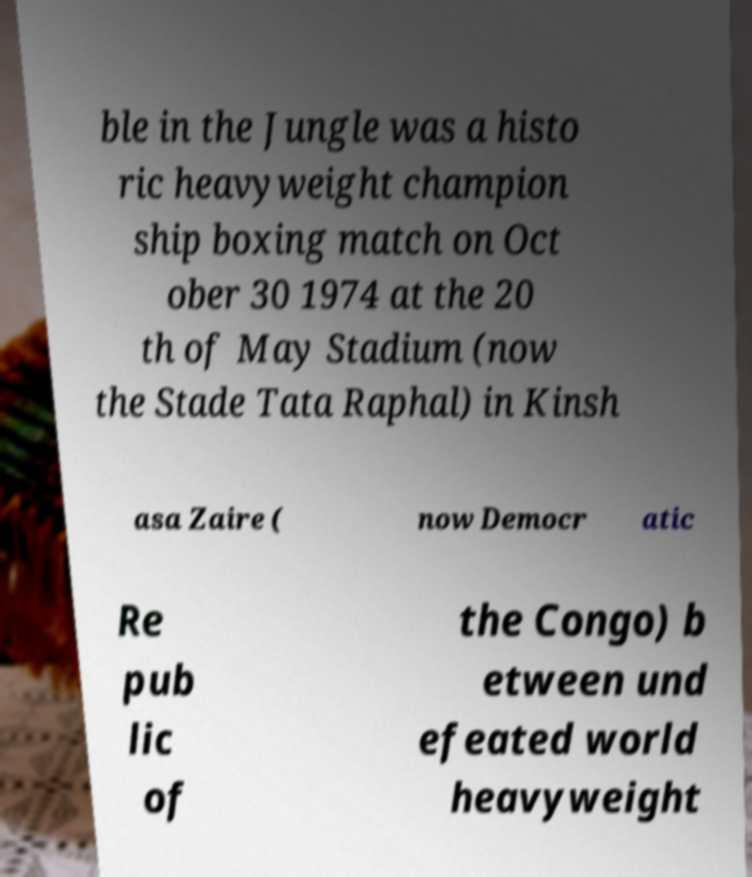Can you accurately transcribe the text from the provided image for me? ble in the Jungle was a histo ric heavyweight champion ship boxing match on Oct ober 30 1974 at the 20 th of May Stadium (now the Stade Tata Raphal) in Kinsh asa Zaire ( now Democr atic Re pub lic of the Congo) b etween und efeated world heavyweight 